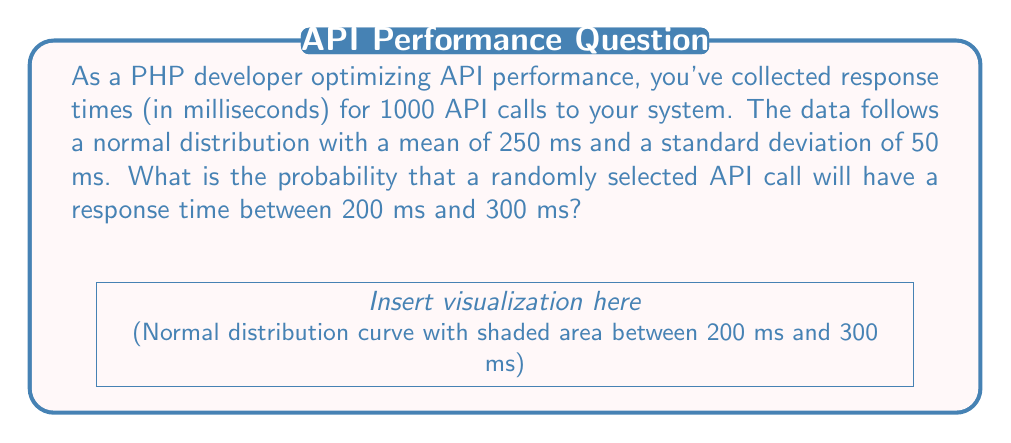Could you help me with this problem? To solve this problem, we'll use the properties of the normal distribution and the concept of z-scores. Here's a step-by-step explanation:

1) We're given that the response times follow a normal distribution with:
   $\mu = 250$ ms (mean)
   $\sigma = 50$ ms (standard deviation)

2) We want to find $P(200 < X < 300)$, where $X$ is the response time.

3) To use the standard normal distribution table, we need to convert these values to z-scores:

   For 200 ms: $z_1 = \frac{200 - 250}{50} = -1$
   For 300 ms: $z_2 = \frac{300 - 250}{50} = 1$

4) Now, we're looking for $P(-1 < Z < 1)$, where $Z$ is the standard normal variable.

5) We can express this as:
   $P(-1 < Z < 1) = P(Z < 1) - P(Z < -1)$

6) Using a standard normal distribution table or calculator:
   $P(Z < 1) \approx 0.8413$
   $P(Z < -1) \approx 0.1587$

7) Therefore:
   $P(-1 < Z < 1) = 0.8413 - 0.1587 = 0.6826$

8) This means there's approximately a 68.26% chance that a randomly selected API call will have a response time between 200 ms and 300 ms.
Answer: 0.6826 or 68.26% 